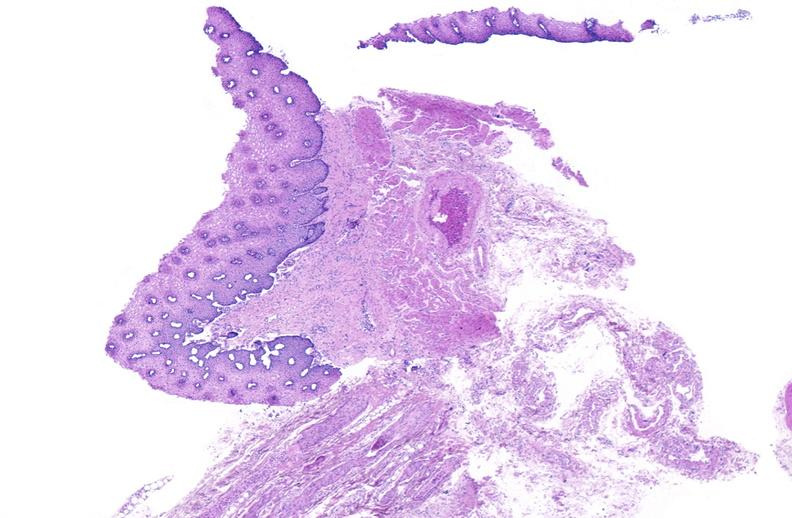s photo present?
Answer the question using a single word or phrase. No 